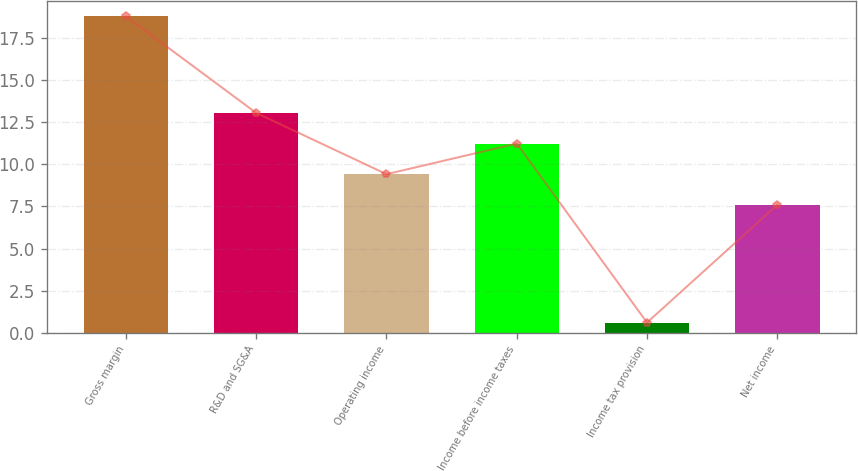Convert chart. <chart><loc_0><loc_0><loc_500><loc_500><bar_chart><fcel>Gross margin<fcel>R&D and SG&A<fcel>Operating income<fcel>Income before income taxes<fcel>Income tax provision<fcel>Net income<nl><fcel>18.8<fcel>13.06<fcel>9.42<fcel>11.24<fcel>0.6<fcel>7.6<nl></chart> 